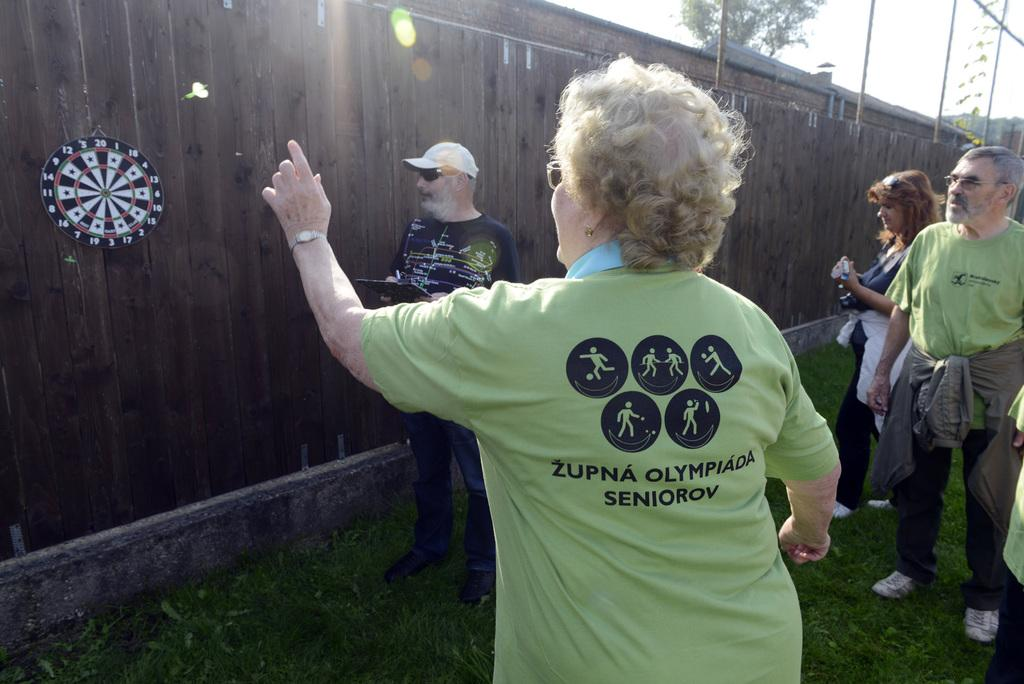What is happening in the image? There are people standing in the image. What type of material is the wall made of? There is a wooden wall in the image. Is there anything attached to the wall? Yes, there is a board attached to the wooden wall. What type of gold branch is hanging from the board in the image? There is no gold branch present in the image. What reward can be seen on the board in the image? There is no reward visible on the board in the image. 